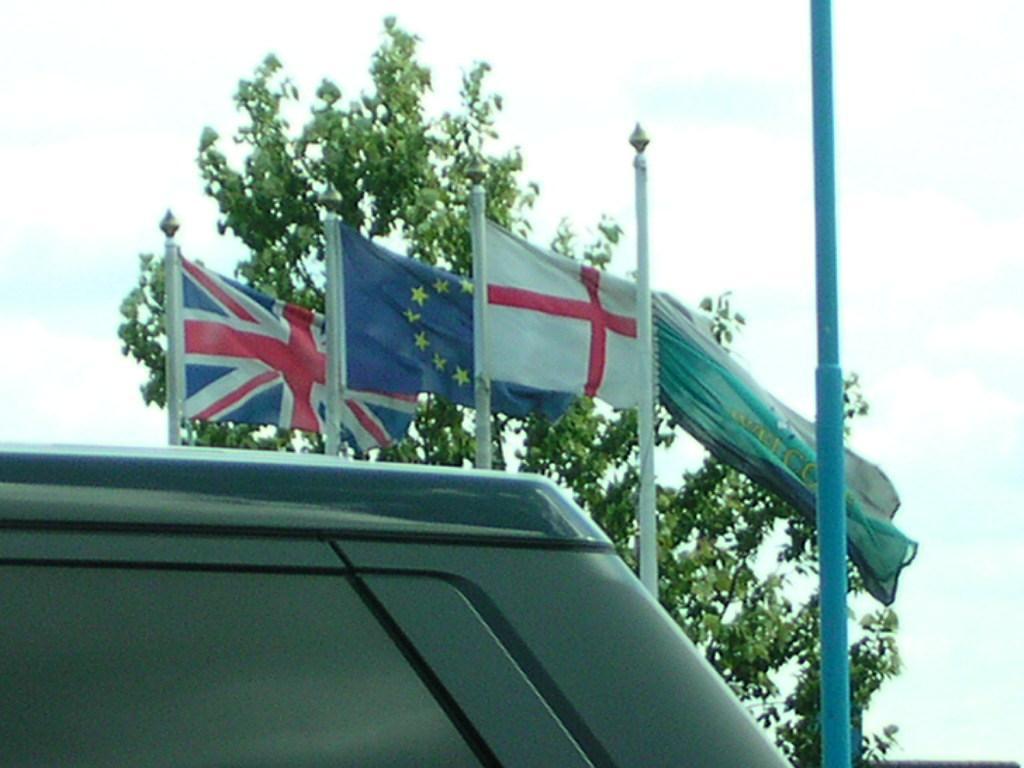Could you give a brief overview of what you see in this image? In this image in front there is an object. In the background there are flags, trees and sky. 